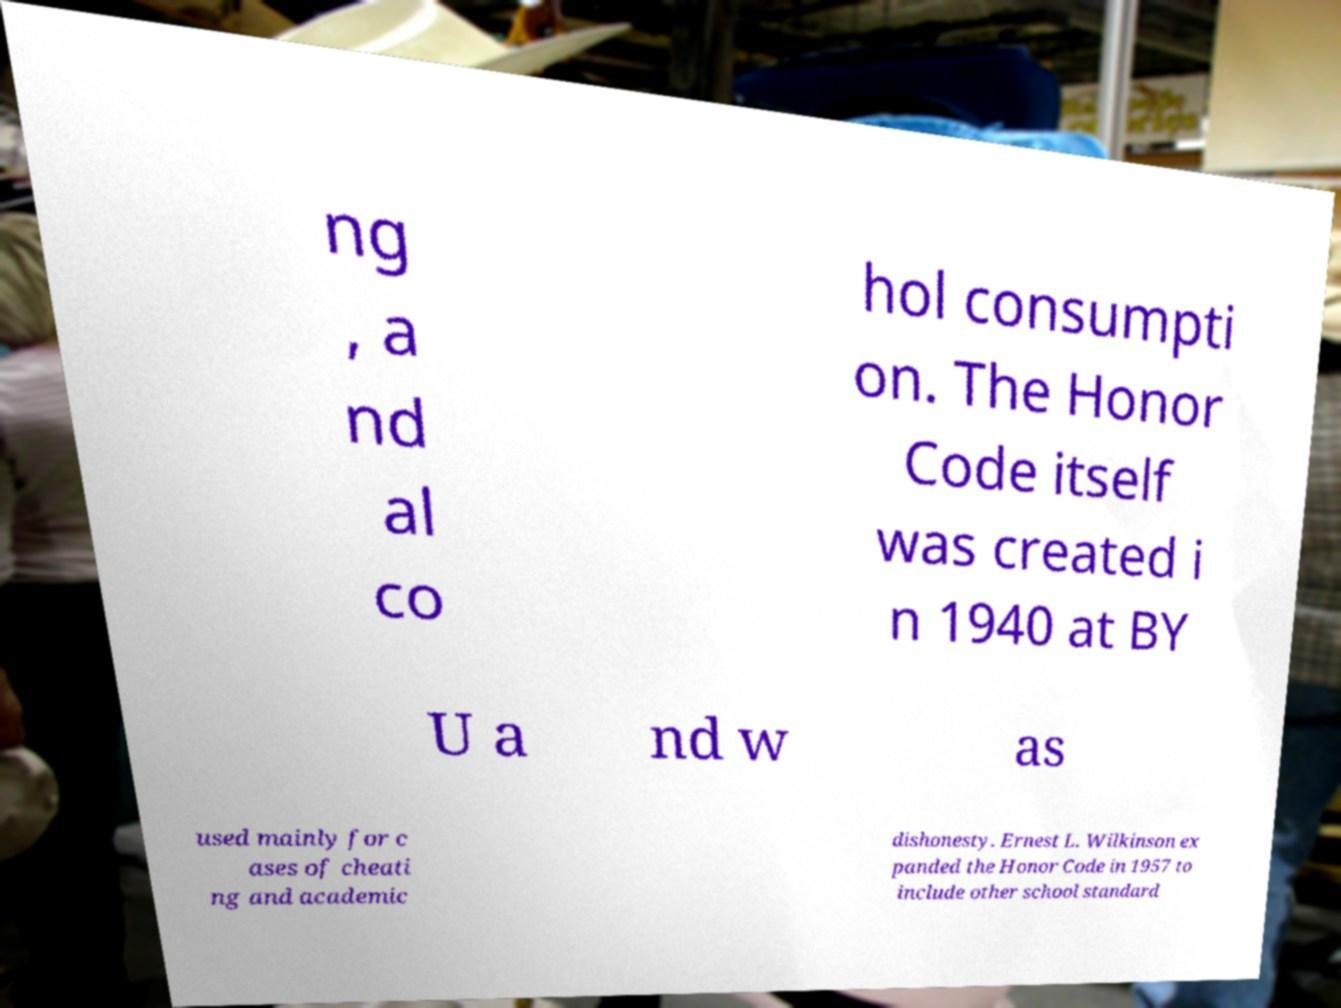Can you read and provide the text displayed in the image?This photo seems to have some interesting text. Can you extract and type it out for me? ng , a nd al co hol consumpti on. The Honor Code itself was created i n 1940 at BY U a nd w as used mainly for c ases of cheati ng and academic dishonesty. Ernest L. Wilkinson ex panded the Honor Code in 1957 to include other school standard 